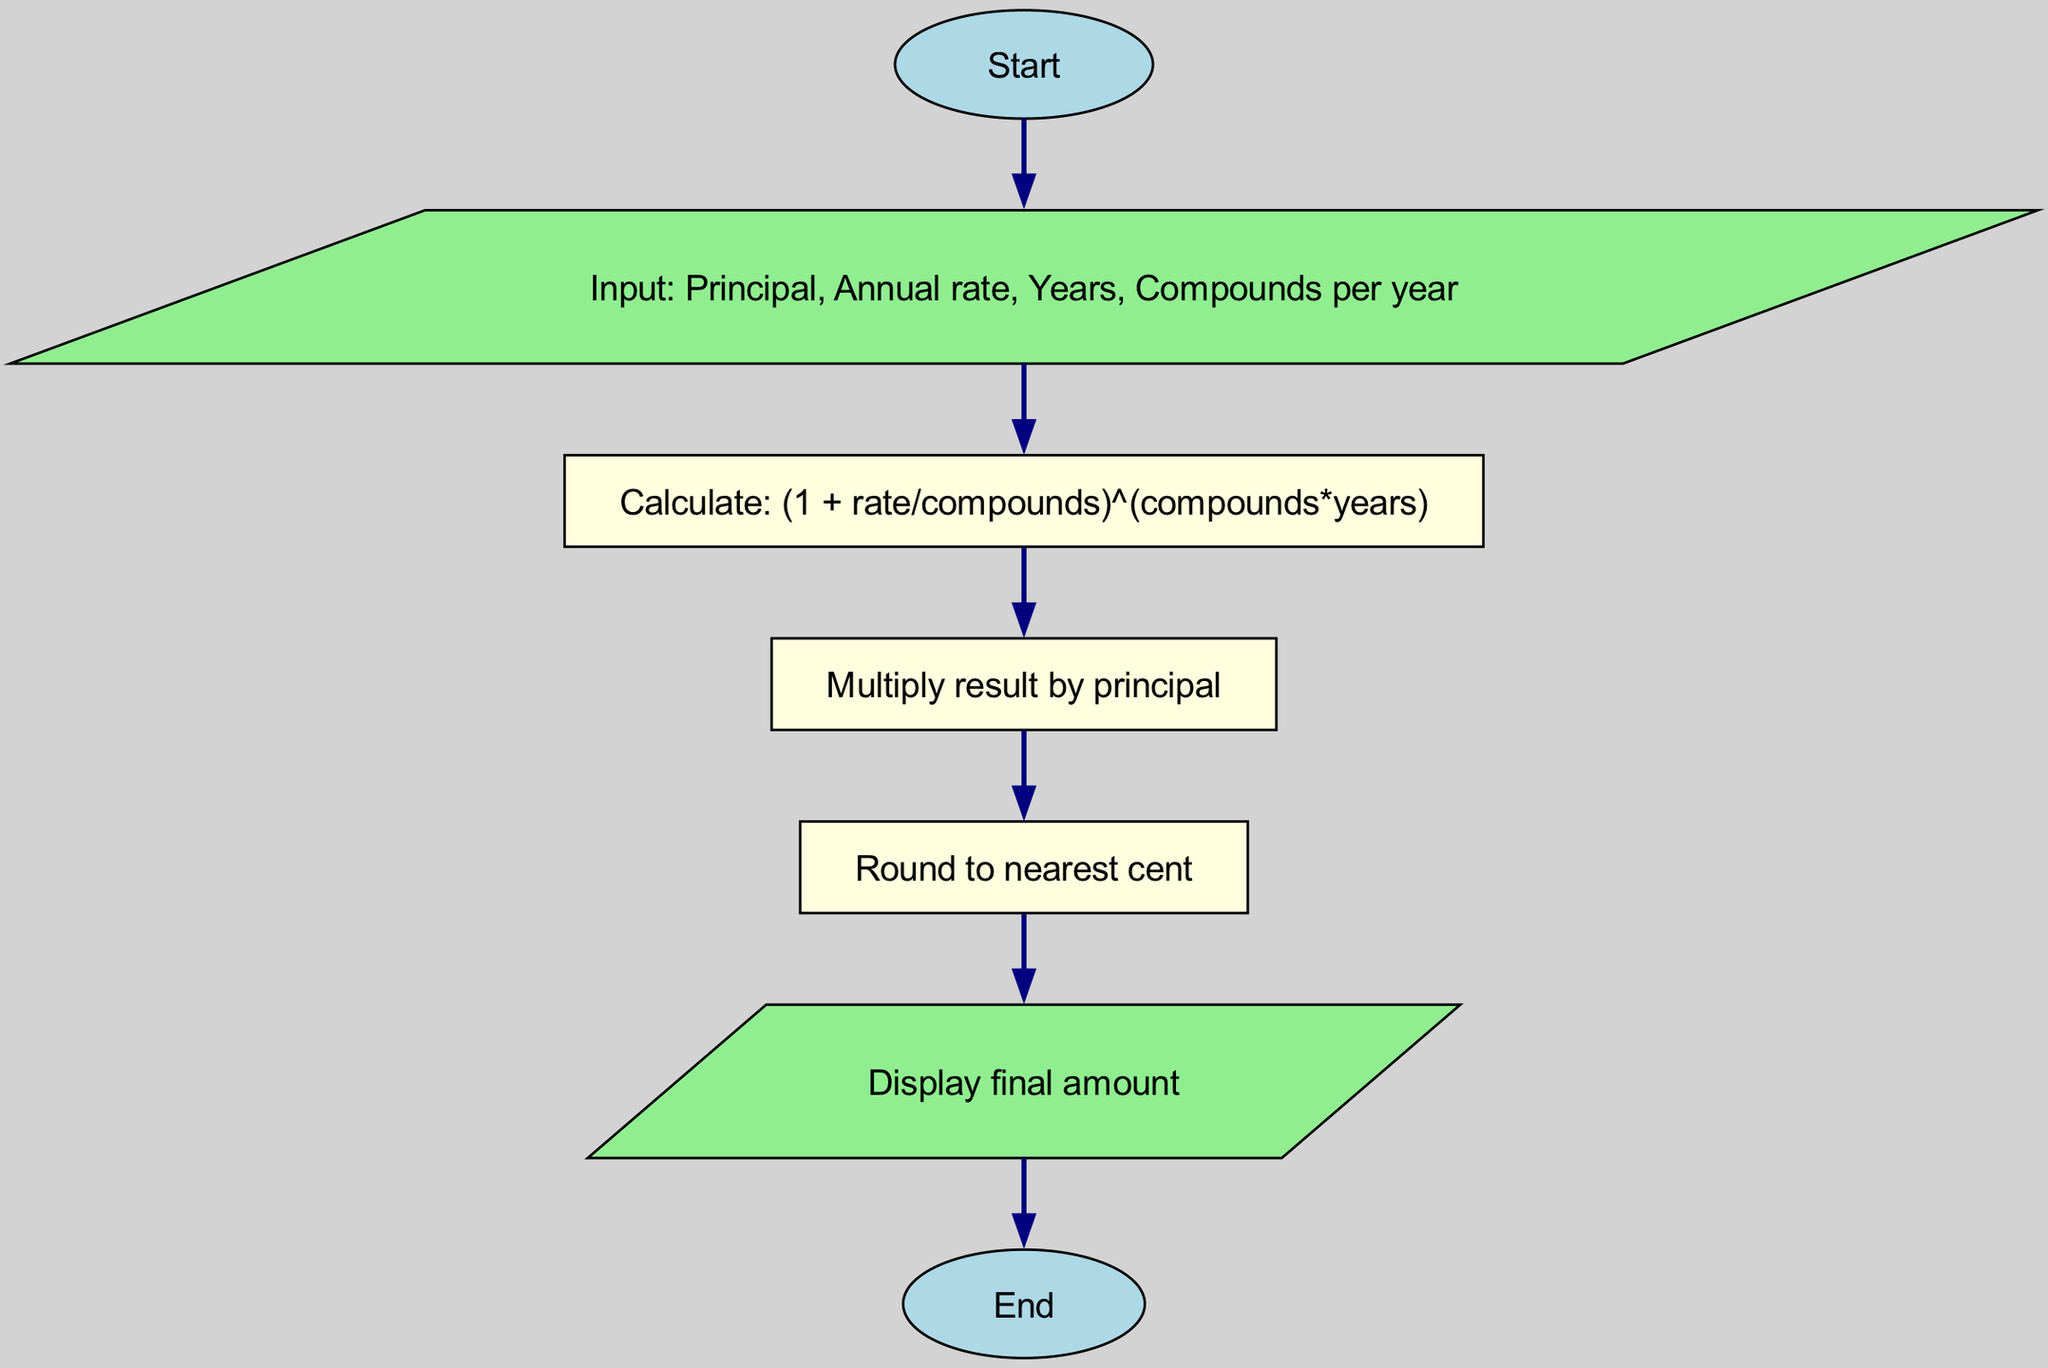What is the first node in the flowchart? The first node in the flowchart is labeled "Start". This is indicated as the first step in the flow of the diagram.
Answer: Start How many edges are there in the flowchart? The flowchart contains five edges. Each edge connects a pair of nodes, guiding the flow from one step to the next.
Answer: 5 What process is performed after inputting the values? After the values are inputted, the next step is to calculate the expression (1 + rate/compounds)^(compounds*years). This is shown as the direct next node in the flow following the input node.
Answer: Calculate: (1 + rate/compounds)^(compounds*years) What type of node is used for the display step? The display step is represented as a parallelogram, which is typically used to indicate input or output operations in flowcharts. This shape is distinctive from the rectangular nodes used for processes.
Answer: Parallelogram What is the last operation before the flowchart ends? The last operation before the flowchart ends is to display the final amount. This is shown as the penultimate step, just before reaching the end node.
Answer: Display final amount How does the flow progress from the "round" node? From the "round" node, the flow proceeds directly to the "display" node. This indicates that after rounding the amount to the nearest cent, the final result is presented as output.
Answer: To "display" node What is calculated in the "multiply" step? In the "multiply" step, the result of the previous calculation is multiplied by the principal. This combines the interest calculation with the initial investment amount to find the total value.
Answer: Multiply result by principal What is the shape of the "input" node? The "input" node is shaped like a parallelogram, which is consistent with flowchart conventions where parallelograms are used to signify input and output actions.
Answer: Parallelogram 